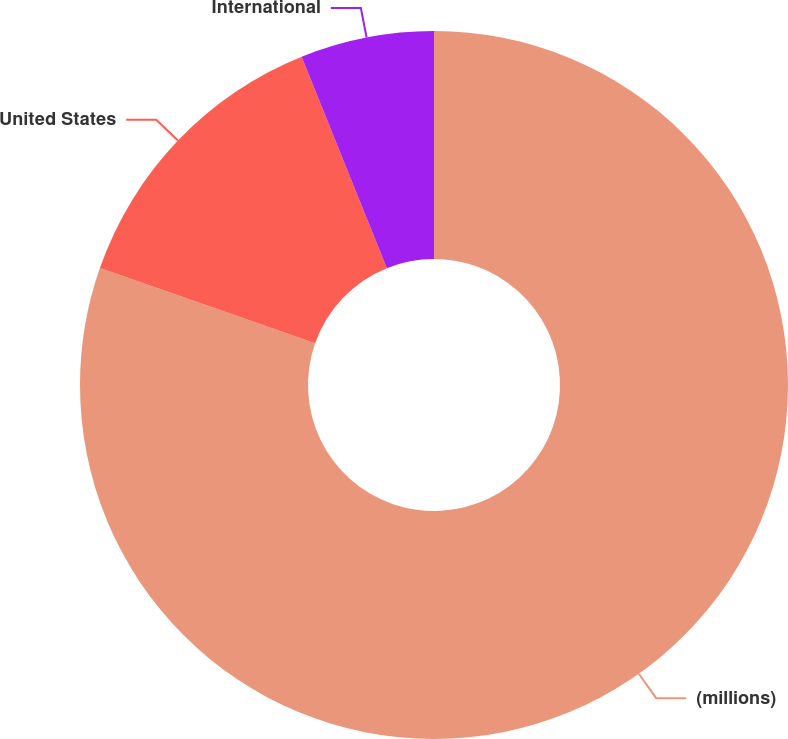<chart> <loc_0><loc_0><loc_500><loc_500><pie_chart><fcel>(millions)<fcel>United States<fcel>International<nl><fcel>80.36%<fcel>13.54%<fcel>6.1%<nl></chart> 